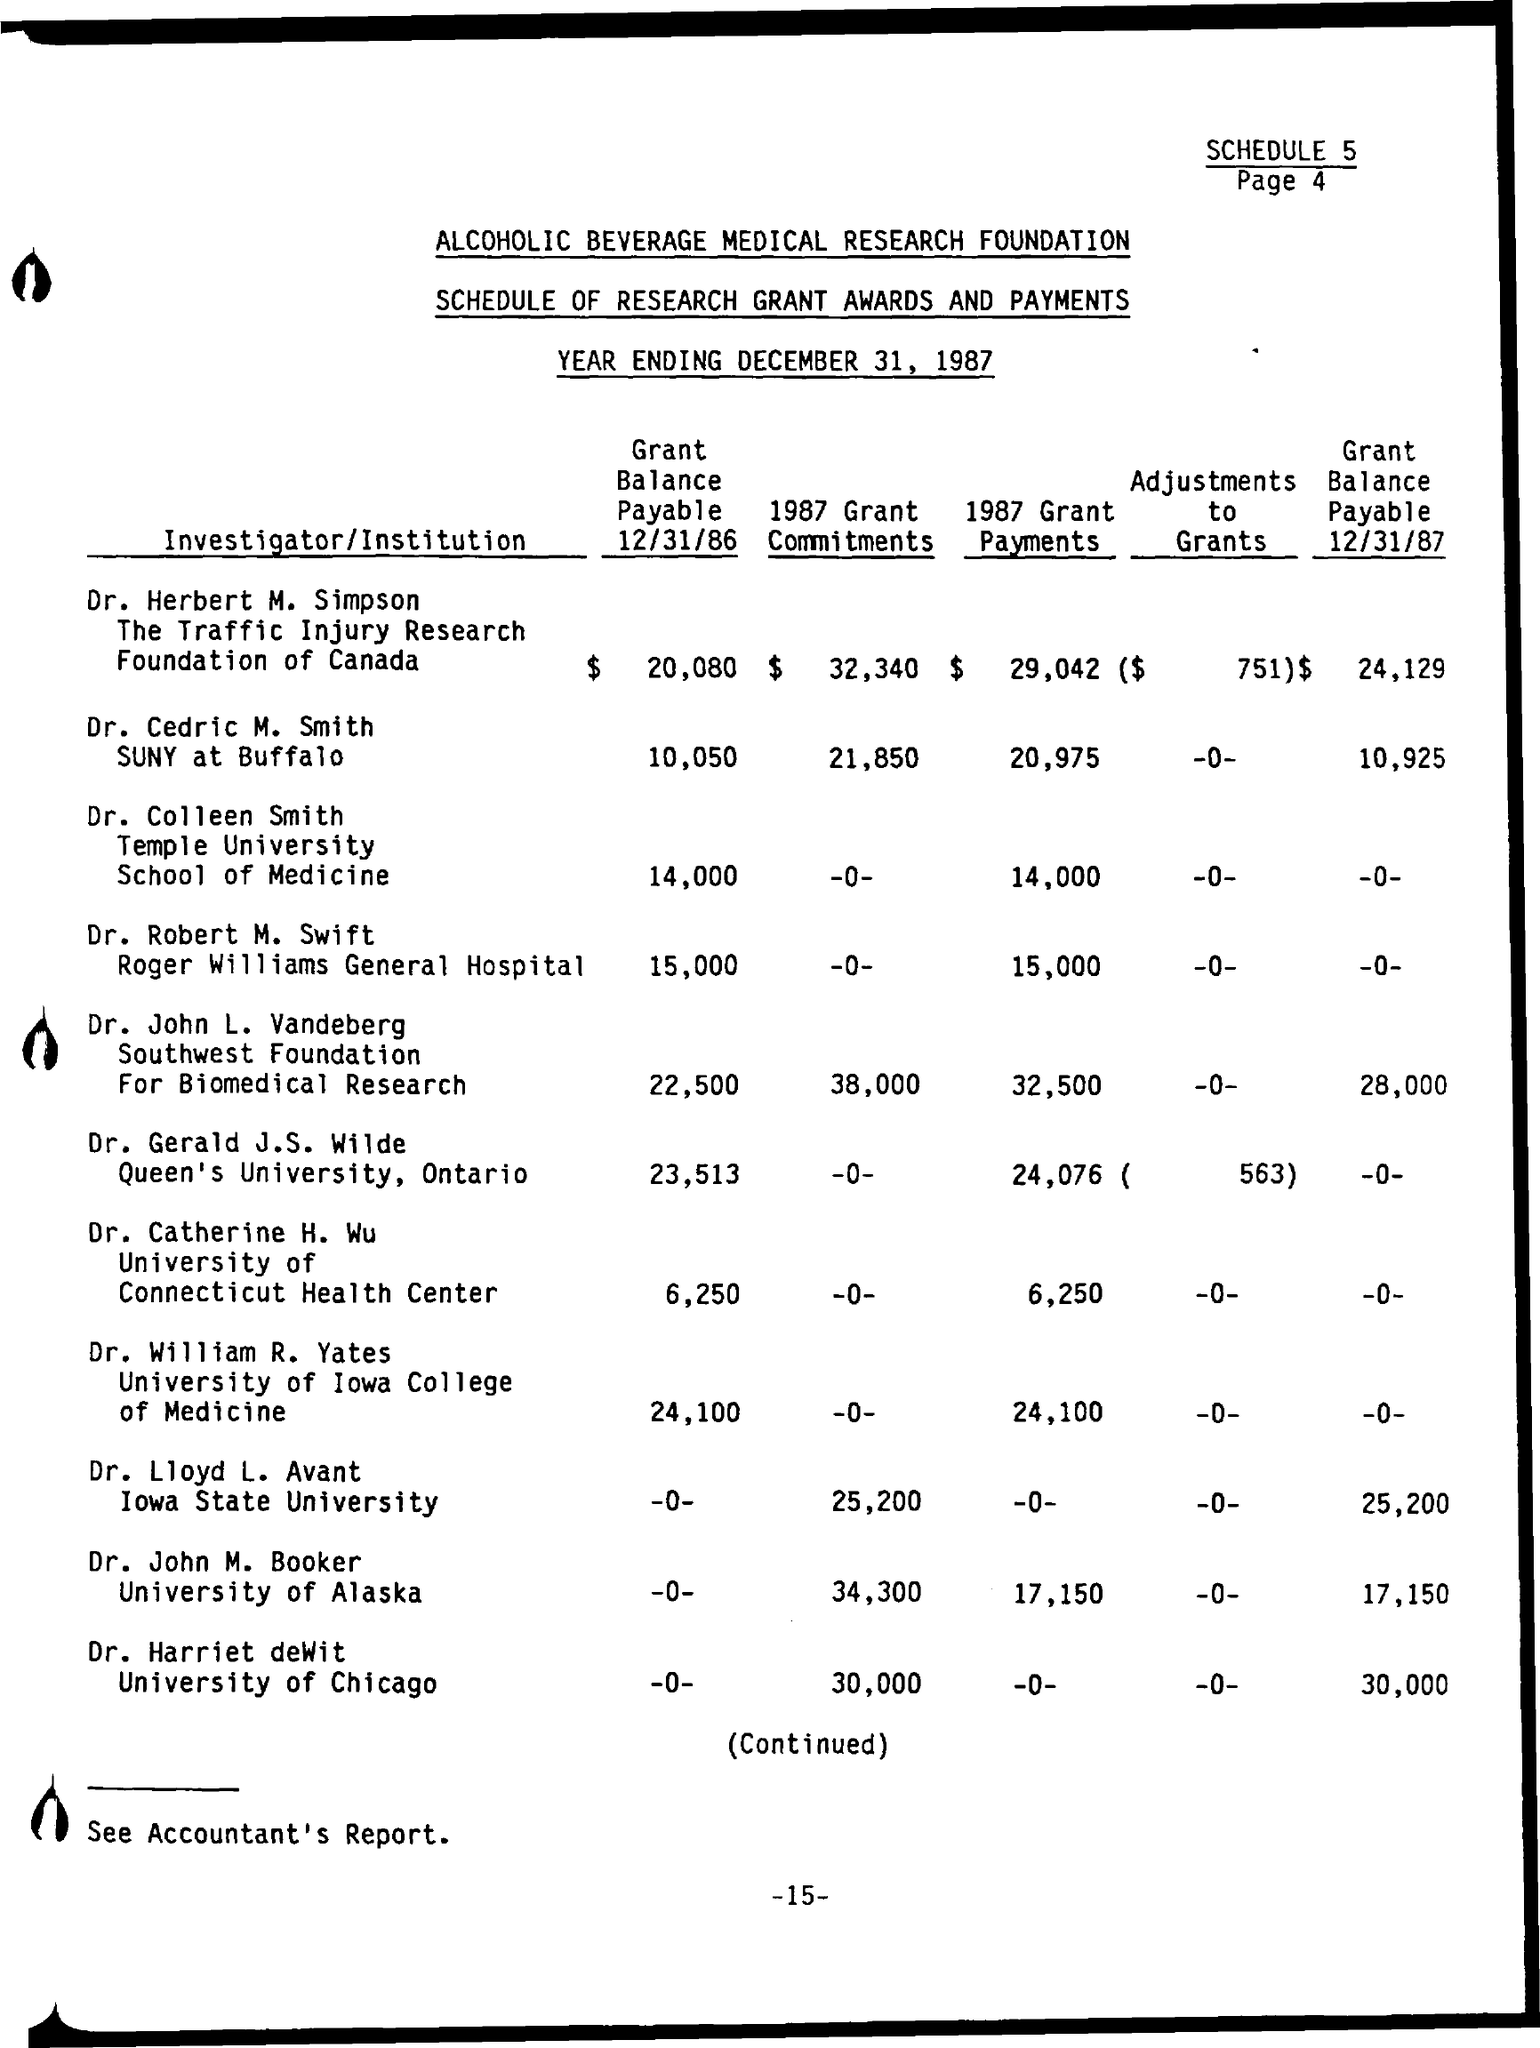What is the Grant Balance Payable 12/31/86 by Dr. Herbert M.Simpson?
Provide a succinct answer. 20,080. What is the Grant Balance Payable 12/31/87 by Dr. Herbert M.Simpson?
Provide a succinct answer. 24,129. What is the Grant Balance Payable 12/31/86 by Dr. Cedric M. Smith?
Your answer should be very brief. 10,050. What is the Grant Balance Payable 12/31/87 by Dr. Cedric M. Smith?
Provide a succinct answer. 10,925. What is the Grant Balance Payable 12/31/86 by Dr. Colleen Smith?
Your response must be concise. 14,000. What is the Grant Balance Payable 12/31/87 by Dr. Colleen Smith?
Your response must be concise. -0-. What is the Grant Balance Payable 12/31/86 by Dr. Robert M. Swift?
Provide a succinct answer. 15,000. What is the Grant Balance Payable 12/31/86 by Dr.John L. Vanderberg?
Ensure brevity in your answer.  22,500. What is the Grant Balance Payable 12/31/87 by Dr.John L. Vanderberg?
Give a very brief answer. 28,000. What is the Grant Balance Payable 12/31/86 by Dr.William R. Yates?
Give a very brief answer. 24,100. 